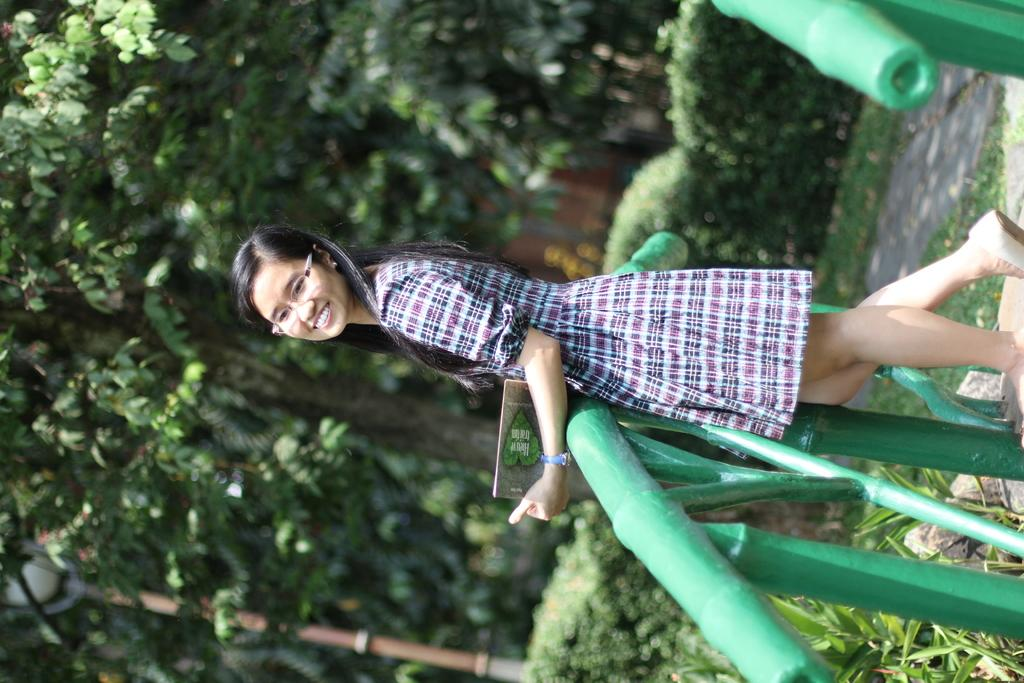Who is present in the image? There is a woman in the image. What is the woman doing in the image? The woman is standing and smiling. What is the woman holding in the image? The woman is holding an object. What type of natural environment can be seen in the image? There is grass, plants, and trees in the image. What type of structure is visible in the image? There is a fence in the image. What type of care does the woman need in the image? There is no indication in the image that the woman needs any care. What type of approval is the woman seeking in the image? There is no indication in the image that the woman is seeking any approval. 